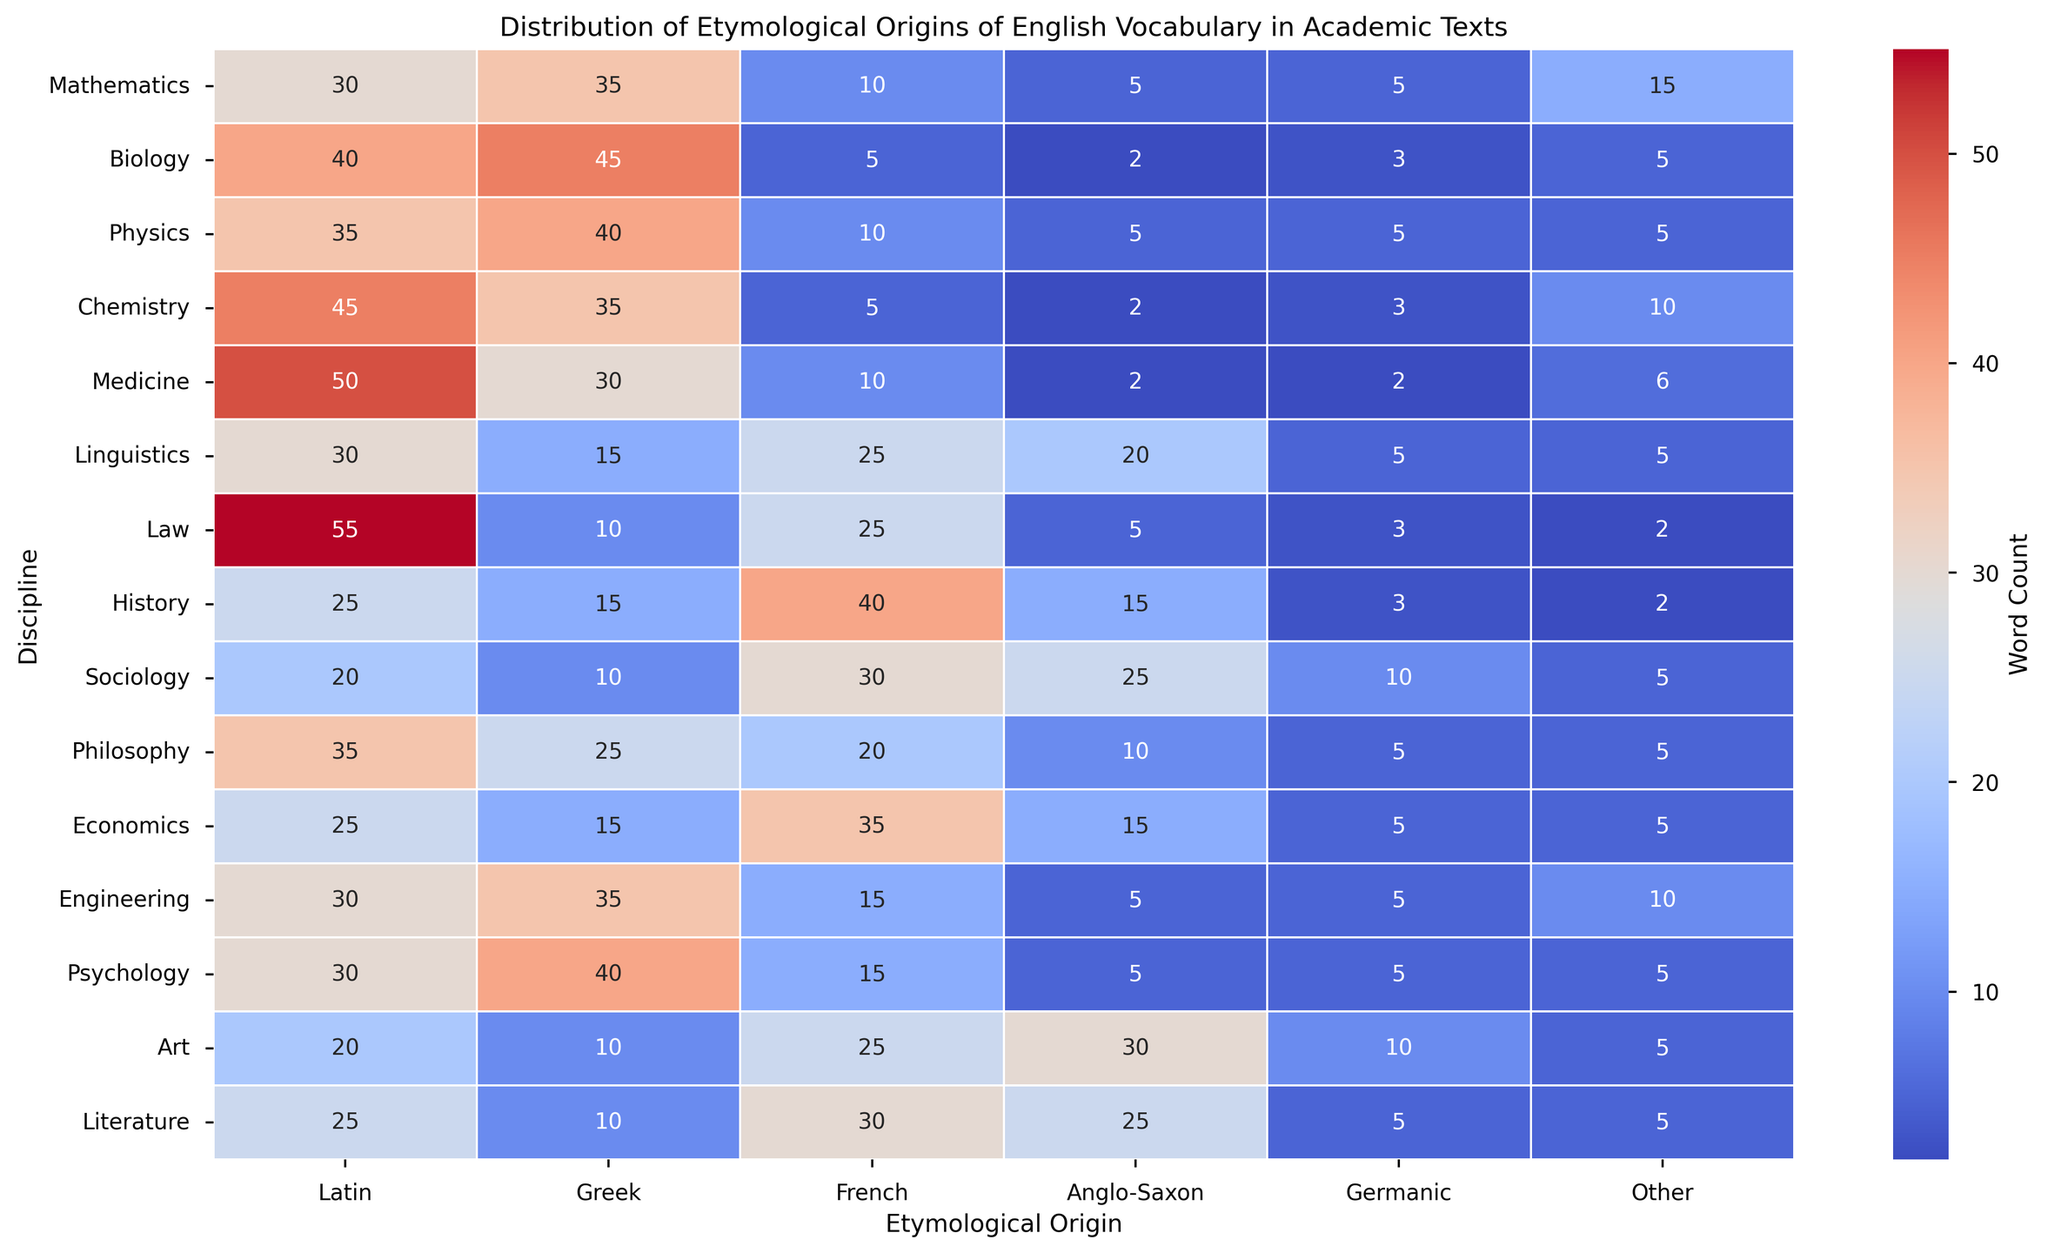What's the discipline with the highest count of Latin-origin words? To identify the discipline with the highest count of Latin-origin words, scan the Latin column and find the maximum value, which is 55, corresponding to the Law discipline.
Answer: Law Which two disciplines have an equal number of Greek-origin words? To determine which disciplines have the same number of Greek-origin words, compare the values in the Greek column. Both Chemistry and Mathematics have 35 Greek-origin words.
Answer: Chemistry and Mathematics What is the difference between the French-origin word counts in History and Sociology? Look at the French column and find the values for History and Sociology. History has 40, and Sociology has 30. Subtract 30 from 40 to get the difference.
Answer: 10 Which discipline has the lowest count of Anglo-Saxon-origin words? Scan the Anglo-Saxon column to find the minimum value, which is 2, corresponding to both Medicine and Biology.
Answer: Medicine and Biology What is the total count of Germanic-origin words across all disciplines? Sum all values in the Germanic column: 5 + 3 + 5 + 3 + 2 + 5 + 3 + 3 + 10 + 5 + 5 + 5 + 5 + 10 + 5 equals 69.
Answer: 69 Which etymological origin is least represented in Literature? Scan the Literature row and identify the lowest value. The least represented etymological origin is Greek, with a count of 10.
Answer: Greek How does the count of Latin-origin words in Philosophy compare to Art? Look at the Latin column for Philosophy (35) and Art (20). Philosophy has more Latin-origin words than Art.
Answer: Philosophy What is the average number of Greek-origin words in STEM disciplines (Mathematics, Biology, Physics, Chemistry, and Engineering)? Sum the Greek-origin words values for these disciplines (35 + 45 + 40 + 35 + 35 = 190) and divide by the number of disciplines (5). The average is 190/5 = 38.
Answer: 38 Is the count of French-origin words in Sociology greater than those in Linguistics and Art combined? French-origin words in Sociology are 30. In Linguistics and Art, they are 25 and 25, respectively, making a combined total of 50. Therefore, 30 is not greater than 50.
Answer: No What is the most visually striking feature of this heatmap with respect to the "Other" category? Scan the "Other" column; the most visually striking feature is the darker shade for Chemistry, indicating the highest count (10) compared to others.
Answer: Chemistry 